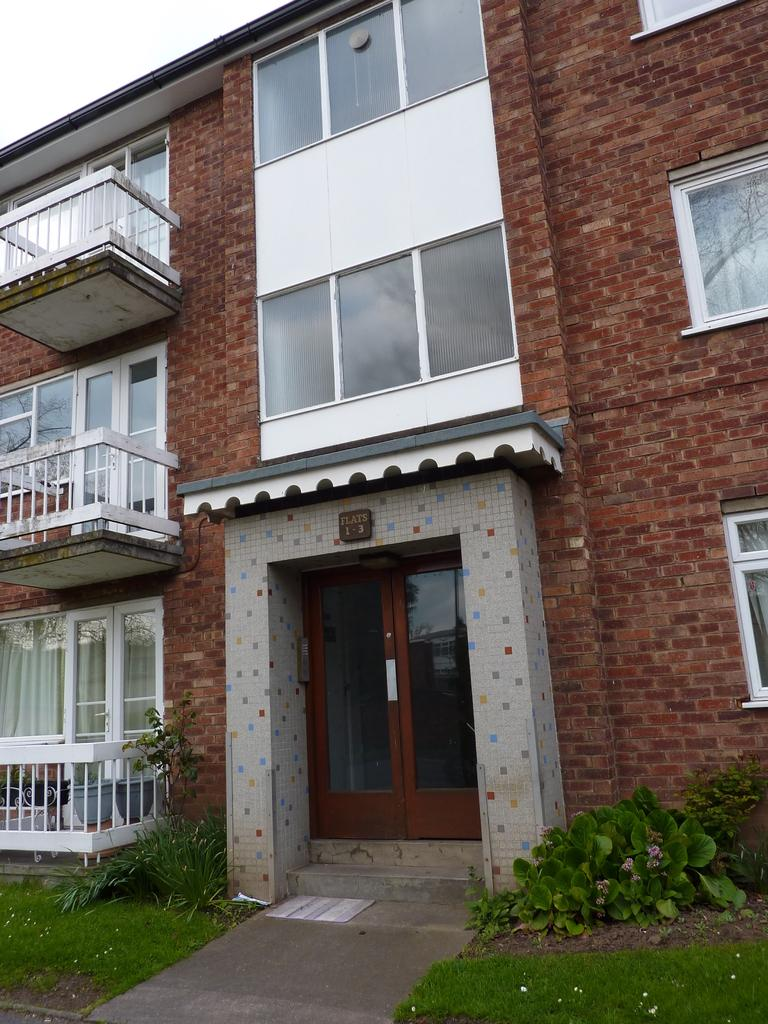What type of natural environment is visible in the image? There is grass in the image, which suggests a natural environment. What other living organisms can be seen in the image? There are plants visible in the image. What type of structure is present in the image? There is a building in the image. What architectural features can be seen on the building? There are windows and a door visible on the building. What is visible in the sky in the image? The sky is visible in the image. What type of sun can be seen on the nose of the person in the image? There is no person present in the image, and therefore no nose or sun on it. What type of light bulb is visible in the image? There is no light bulb present in the image. 